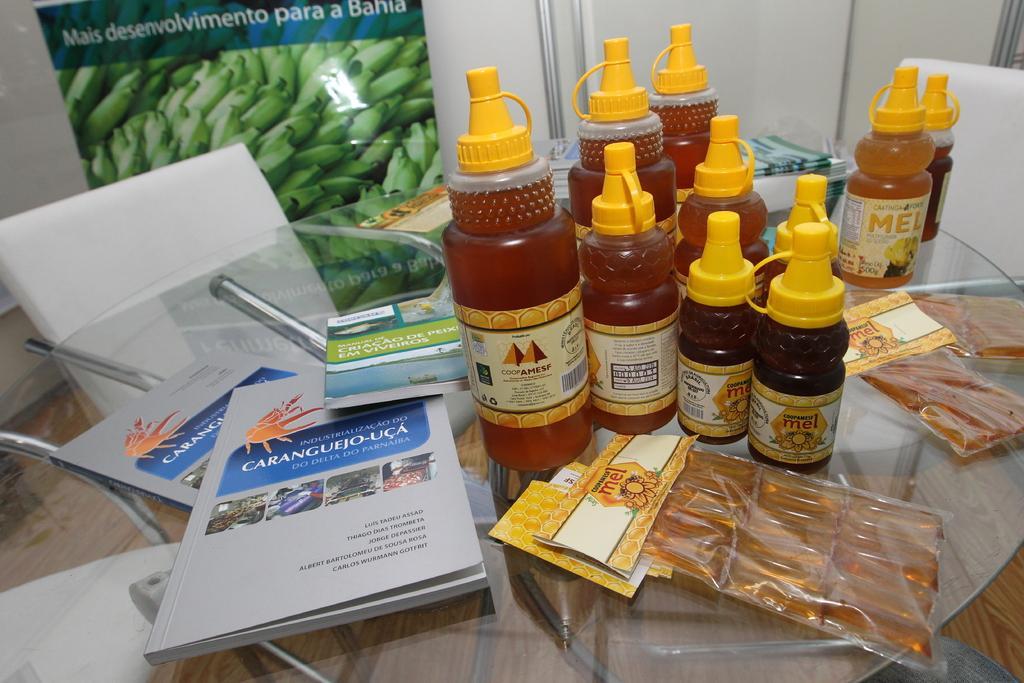Please provide a concise description of this image. This picture is clicked inside room. Here, we see table in front of this picture, and on table we can see many bottles with honey in it and even some plastic cover with some liquid in it and on the table, we see book and covers, and we can see chairs around this table and behind this table, we see a wall which is white in color and on the wall we can see a banner with some text written on it and and with some raw bananas on that picture. 